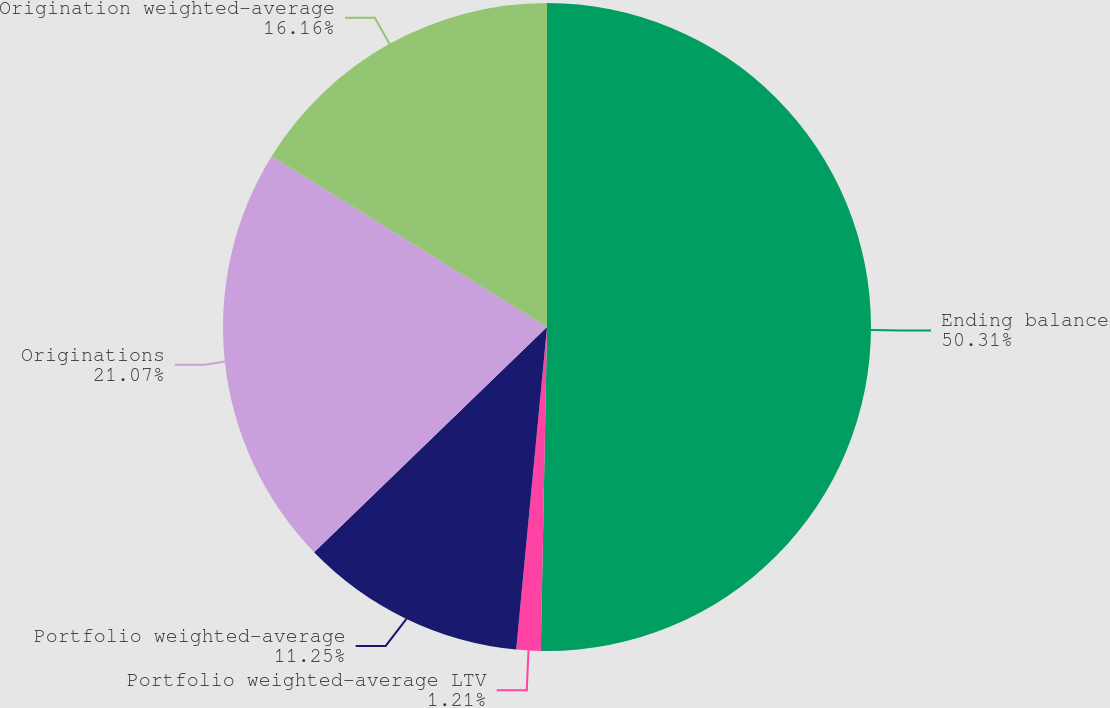<chart> <loc_0><loc_0><loc_500><loc_500><pie_chart><fcel>Ending balance<fcel>Portfolio weighted-average LTV<fcel>Portfolio weighted-average<fcel>Originations<fcel>Origination weighted-average<nl><fcel>50.3%<fcel>1.21%<fcel>11.25%<fcel>21.07%<fcel>16.16%<nl></chart> 